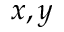<formula> <loc_0><loc_0><loc_500><loc_500>x , y</formula> 